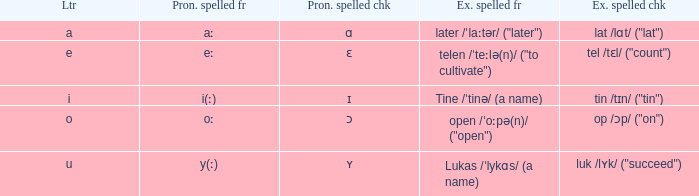What is Pronunciation Spelled Checked, when Example Spelled Checked is "tin /tɪn/ ("tin")" Ɪ. 